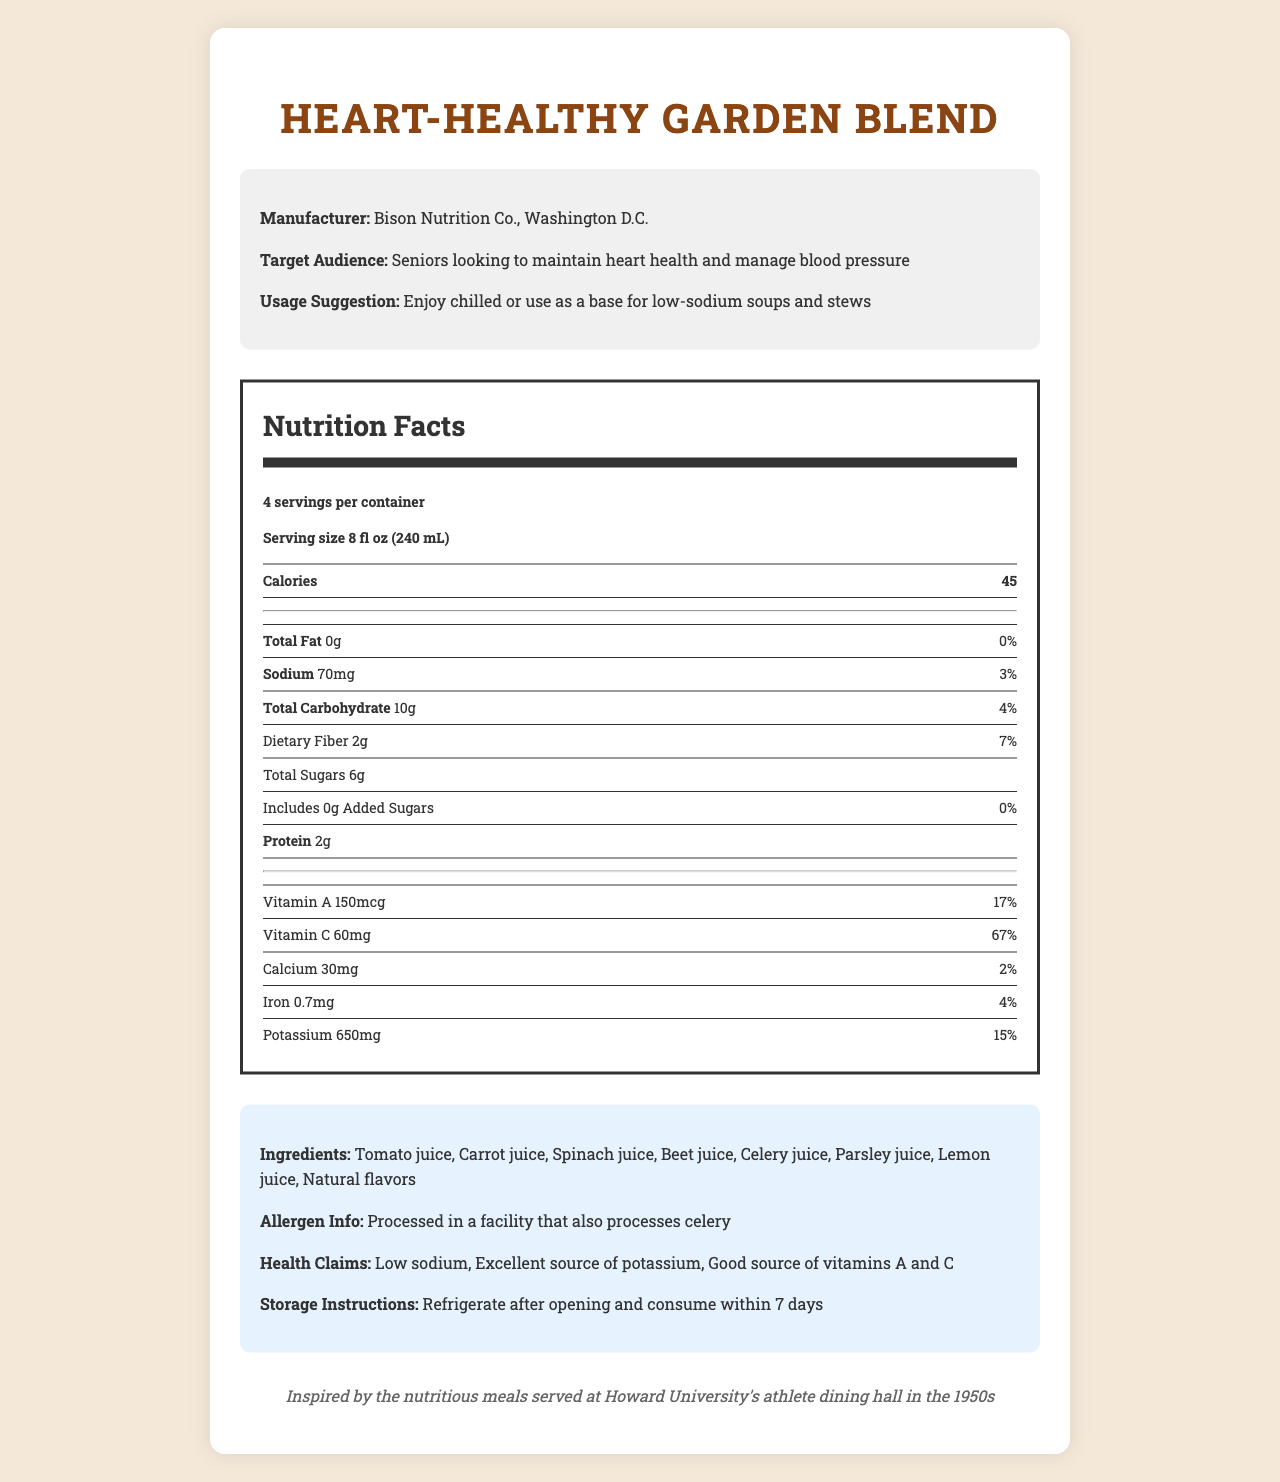what is the serving size of the Heart-Healthy Garden Blend? The serving size is listed near the top of the nutrition label as "serving size: 8 fl oz (240 mL)".
Answer: 8 fl oz (240 mL) how many servings are there per container? The nutrition label specifies that there are 4 servings per container.
Answer: 4 what is the amount of sodium per serving? The nutrition label lists sodium content as 70mg per serving.
Answer: 70mg how much potassium is in each serving and what is its daily value percentage? The nutrition label lists potassium as having 650mg per serving, which is 15% of the daily value.
Answer: 650mg, 15% what are the main ingredients in this vegetable juice? The ingredients list in the extra info section includes these ingredients.
Answer: Tomato juice, Carrot juice, Spinach juice, Beet juice, Celery juice, Parsley juice, Lemon juice, Natural flavors what is the manufacturer of this juice blend? A. Howard Nutrition Co. B. Bison Nutrition Co. C. Washington D.C. Juice Co. The document states that the manufacturer is Bison Nutrition Co., Washington D.C.
Answer: B which of the following is a health claim made by the product? I. Low sodium II. High in protein III. Excellent source of potassium The health claims listed are "Low sodium" and "Excellent source of potassium".
Answer: I and III is this juice an excellent source of Vitamin C? The nutrition label shows that Vitamin C content is 60mg, which is 67% of the daily value, qualifying it as an excellent source.
Answer: Yes summarize the information provided in the document. The explanation includes the primary nutritional content, specific health claims, manufacturer details, inspiration behind the product, and additional information such as allergen info and usage suggestions.
Answer: This document provides detailed Nutrition Facts for the Heart-Healthy Garden Blend, a low-sodium, potassium-rich vegetable juice blend aimed at seniors looking to maintain heart health and manage blood pressure. Each 8 fl oz serving contains 45 calories, 0g total fat, 70mg sodium, 650mg potassium, among other nutrients. The product boasts health claims such as being low in sodium and an excellent source of potassium and vitamins A and C. It is manufactured by Bison Nutrition Co., Washington D.C., and inspired by meals served at Howard University's athlete dining hall in the 1950s. The label also includes storage instructions, allergen info, and usage suggestions. what is the specific percentage of daily value for calcium in each serving of the juice? The nutrition label indicates that each serving contains 30mg of calcium, which is 2% of the daily value.
Answer: 2% does the juice contain any added sugars? The nutrition label clearly states that total added sugars are 0g.
Answer: No how many grams of dietary fiber are in a serving? The nutrition label specifies that each serving contains 2g of dietary fiber.
Answer: 2g who is the target audience for this product? The document states that the target audience is seniors looking to maintain heart health and manage blood pressure.
Answer: Seniors looking to maintain heart health and manage blood pressure for how long should the juice be consumed after opening? The storage instructions state that the juice should be refrigerated after opening and consumed within 7 days.
Answer: 7 days how does the juice blend contribute to Vitamin A intake? The nutrition label indicates that each serving contains 150mcg of Vitamin A, amounting to 17% of the daily value.
Answer: 150mcg, 17% how many grams of total fat are in one serving of the vegetable juice? The nutrition label indicates that the total fat content per serving is 0g.
Answer: 0g what is the inspiration behind this juice blend? The document notes that the product was inspired by the nutritious meals served at Howard University's athlete dining hall in the 1950s.
Answer: Inspired by the nutritious meals served at Howard University's athlete dining hall in the 1950s is it clear if the juice is organic? The document does not provide any information regarding whether the juice is organic or not.
Answer: Cannot be determined 